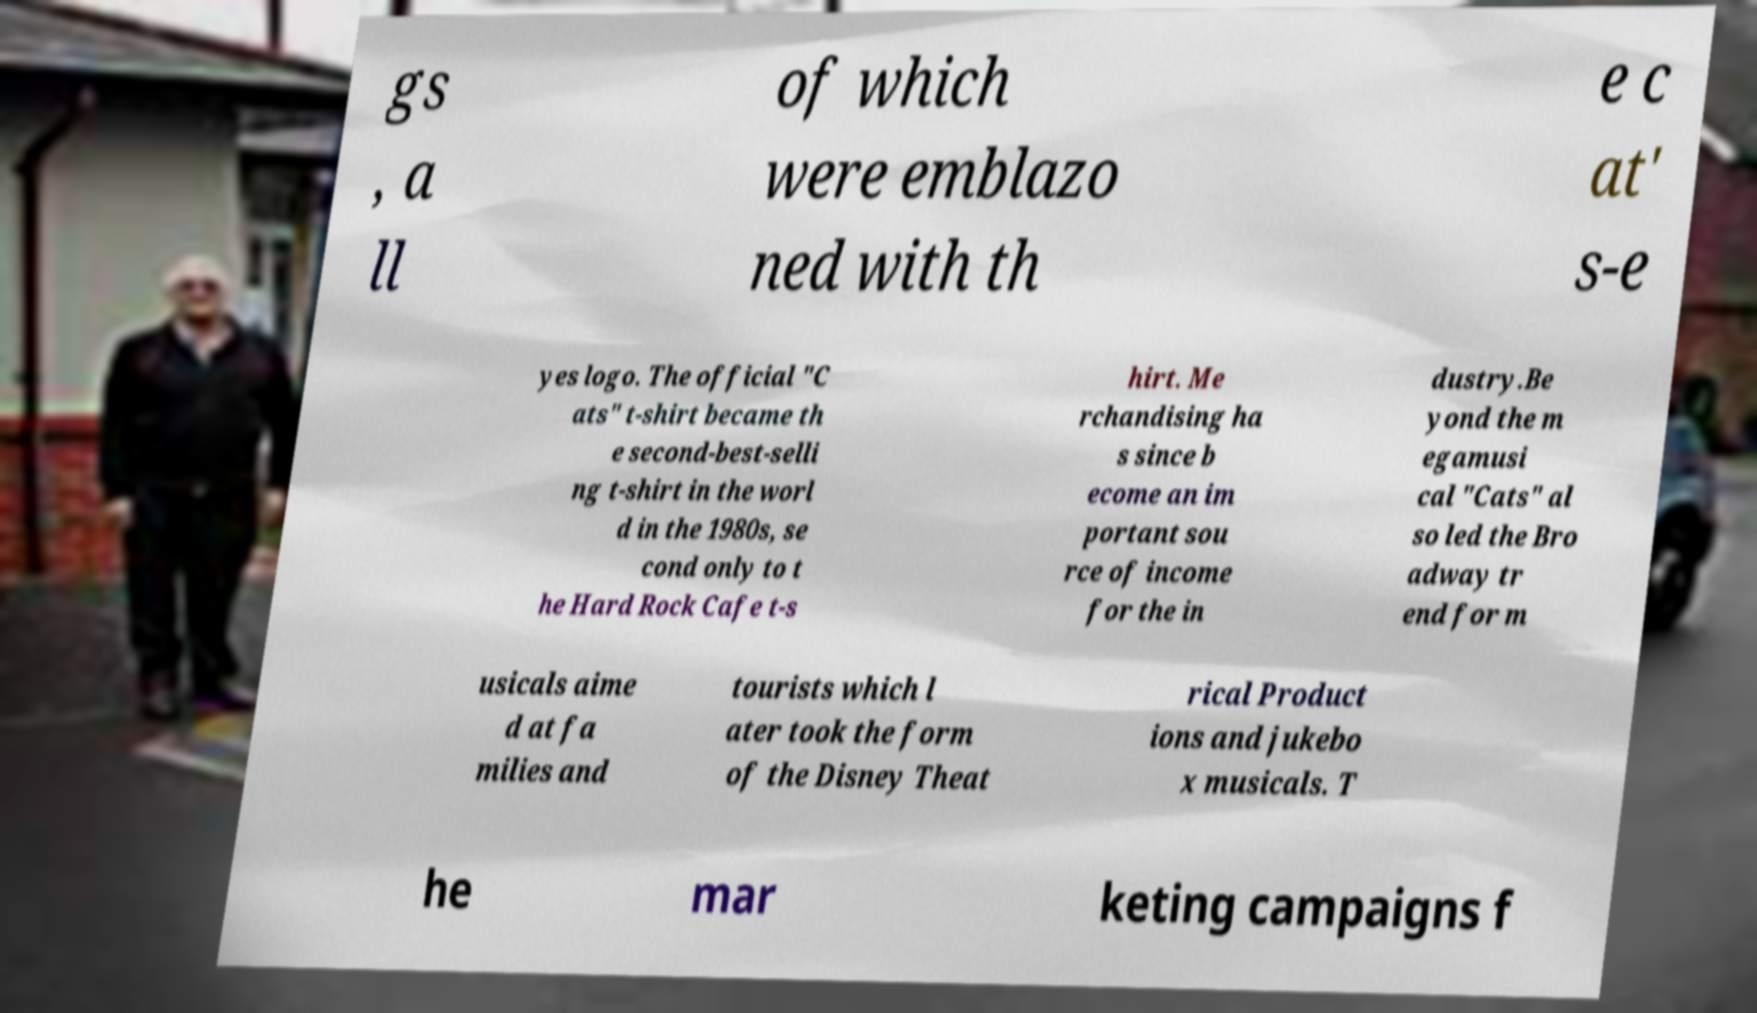Can you read and provide the text displayed in the image?This photo seems to have some interesting text. Can you extract and type it out for me? gs , a ll of which were emblazo ned with th e c at' s-e yes logo. The official "C ats" t-shirt became th e second-best-selli ng t-shirt in the worl d in the 1980s, se cond only to t he Hard Rock Cafe t-s hirt. Me rchandising ha s since b ecome an im portant sou rce of income for the in dustry.Be yond the m egamusi cal "Cats" al so led the Bro adway tr end for m usicals aime d at fa milies and tourists which l ater took the form of the Disney Theat rical Product ions and jukebo x musicals. T he mar keting campaigns f 